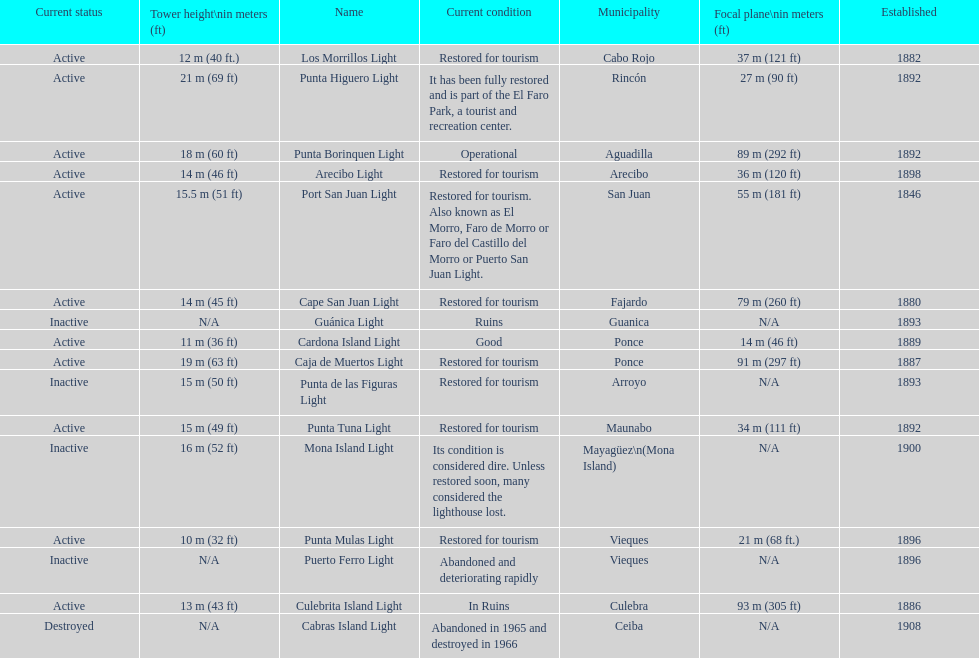Were any towers established before the year 1800? No. 